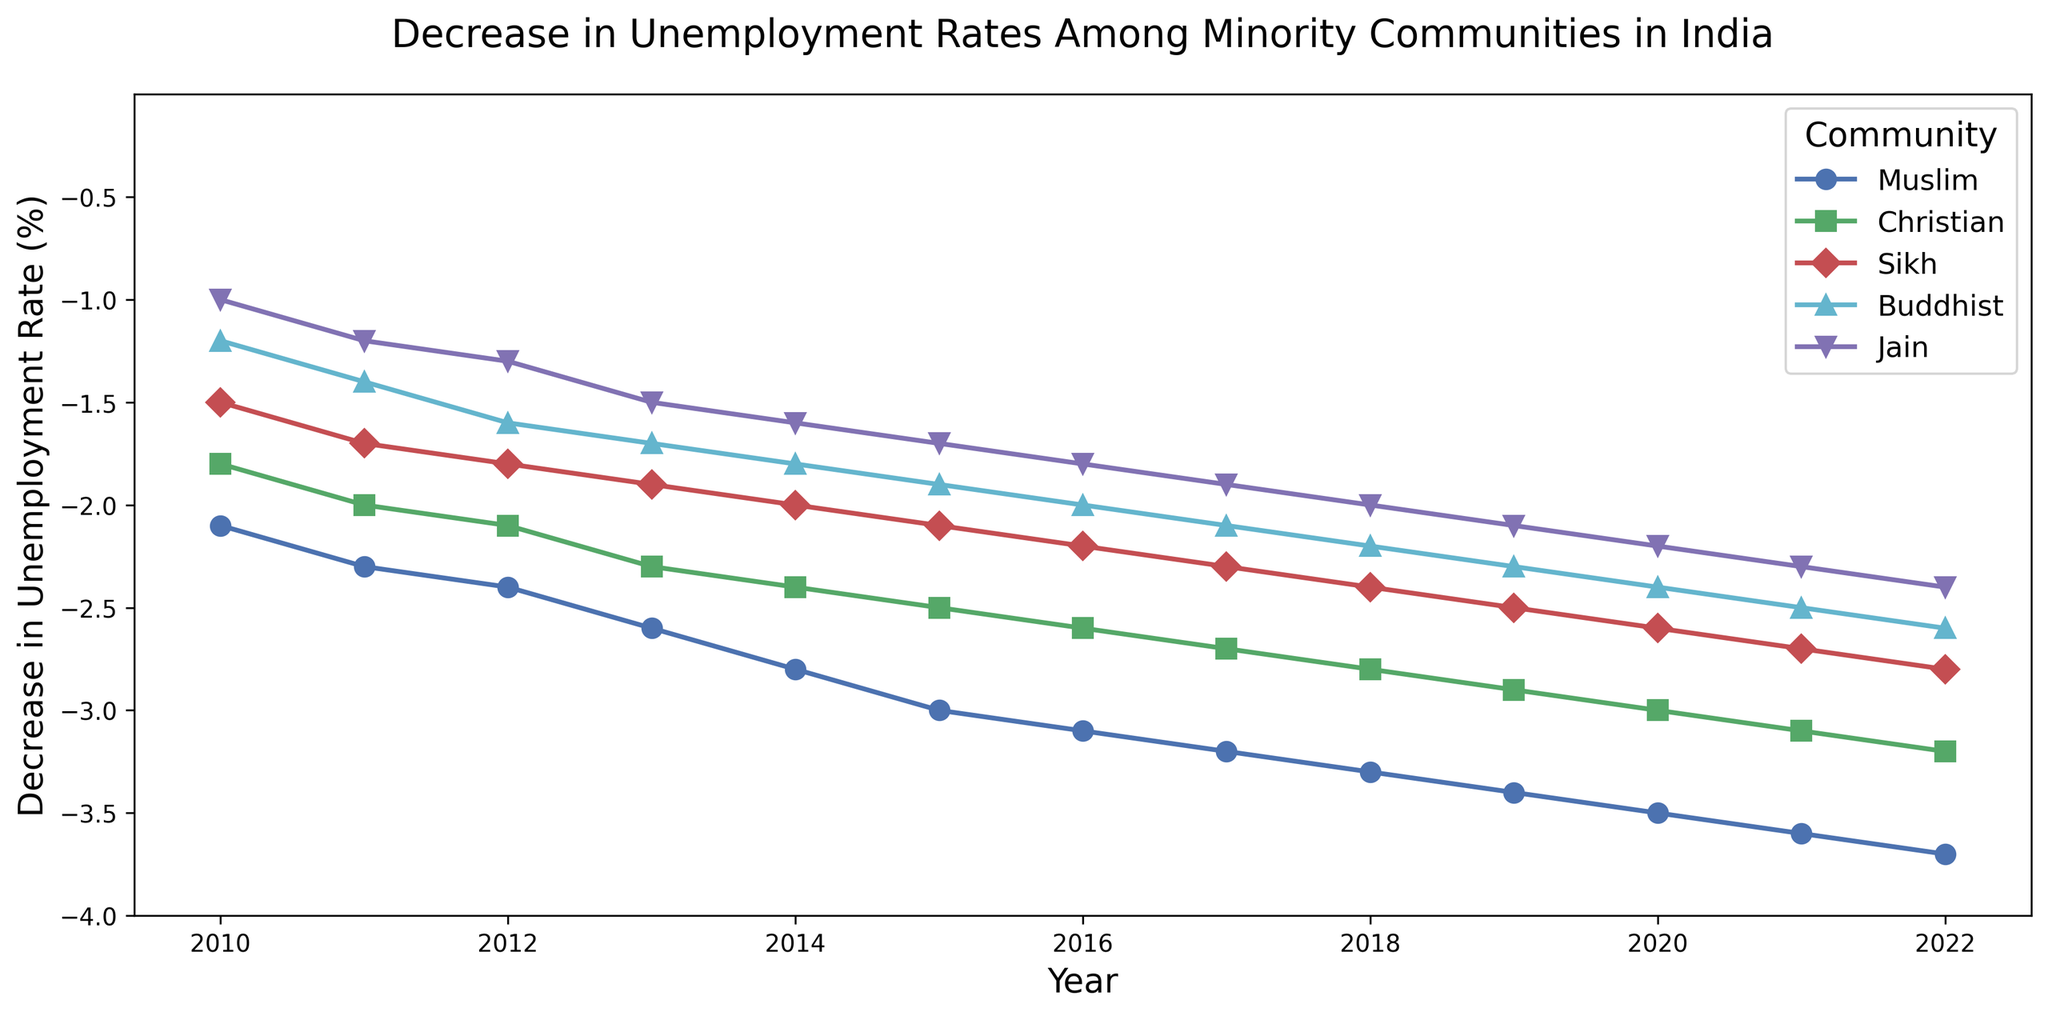Which community had the largest decrease in unemployment rate in 2020? From the figure, observe which community had the lowest point (most negative value) in the year 2020. The Muslim community had the largest decrease in unemployment rate at -3.5%.
Answer: Muslim Between 2010 and 2022, which community consistently had the smallest decrease in unemployment rate? By following the line plots for each community across the years from 2010 to 2022, observe which community's line consistently remains higher (closer to 0 but still negative) compared to others. The Jain community had the smallest consistent decrease.
Answer: Jain What's the average decrease in unemployment rate for the Christian community from 2010 to 2013? Sum the values for the Christian community from 2010 (-1.8), 2011 (-2.0), 2012 (-2.1), and 2013 (-2.3) and divide by the number of years. The calculation is (-1.8 + -2.0 + -2.1 + -2.3) / 4 = -2.05.
Answer: -2.05 Compare the decrease in unemployment rate between the Sikh and Buddhist communities in 2019. Which community had a greater decrease? Look at the 2019 data points for the Sikh and Buddhist communities. The Sikh community had a decrease of -2.5%, and the Buddhist community had a decrease of -2.3%. The Sikh community had a greater decrease.
Answer: Sikh How did the decrease in unemployment rate for the Muslim community change from 2010 to 2016? Note the values for the Muslim community in 2010 (-2.1) and 2016 (-3.1). The change over these years is calculated as -3.1 - (-2.1) = -1.0, indicating a further decrease by 1.0%.
Answer: -1.0% What is the difference in the decrease in unemployment rate between the Buddhist community in 2015 and 2018? From the figure, identify the decrease in unemployment rate for the Buddhist community in 2015 (-1.9) and in 2018 (-2.2). The difference is calculated as -2.2 - (-1.9) = -0.3.
Answer: -0.3 In which year did the Christian community experience the largest yearly decrease in unemployment rate? Check the yearly changes for the Christian community and find where the difference is maximal. The largest decrease occurred between 2019 (-2.9) and 2020 (-3.0), which is a difference of -0.1.
Answer: 2020 Compare the trends for the Sikh and Muslim communities. Did both communities have a reduction in unemployment rate every year from 2010 to 2022? By comparing the line plots for the Sikh and Muslim communities year by year from 2010 to 2022, observe that both communities' lines consistently decrease (move downward) each year, indicating a reduction in unemployment rate every year.
Answer: Yes When did the Jain community reach a decrease in unemployment rate of more than -2.0%? Look at the data for the Jain community and identify the first year it crossed the -2.0% mark. The Jain community first reached more than -2.0% in 2018 with a decrease of -2.0%.
Answer: 2018 What was the total decrease in unemployment rate for the Muslim community over the span from 2010 to 2022? Sum the yearly decreases in unemployment rate for the Muslim community from 2010 (-2.1) to 2022 (-3.7). The total decrease is -2.1 -2.3 -2.4 -2.6 -2.8 -3.0 -3.1 -3.2 -3.3 -3.4 -3.5 -3.6 -3.7 = -38.0.
Answer: -38.0 